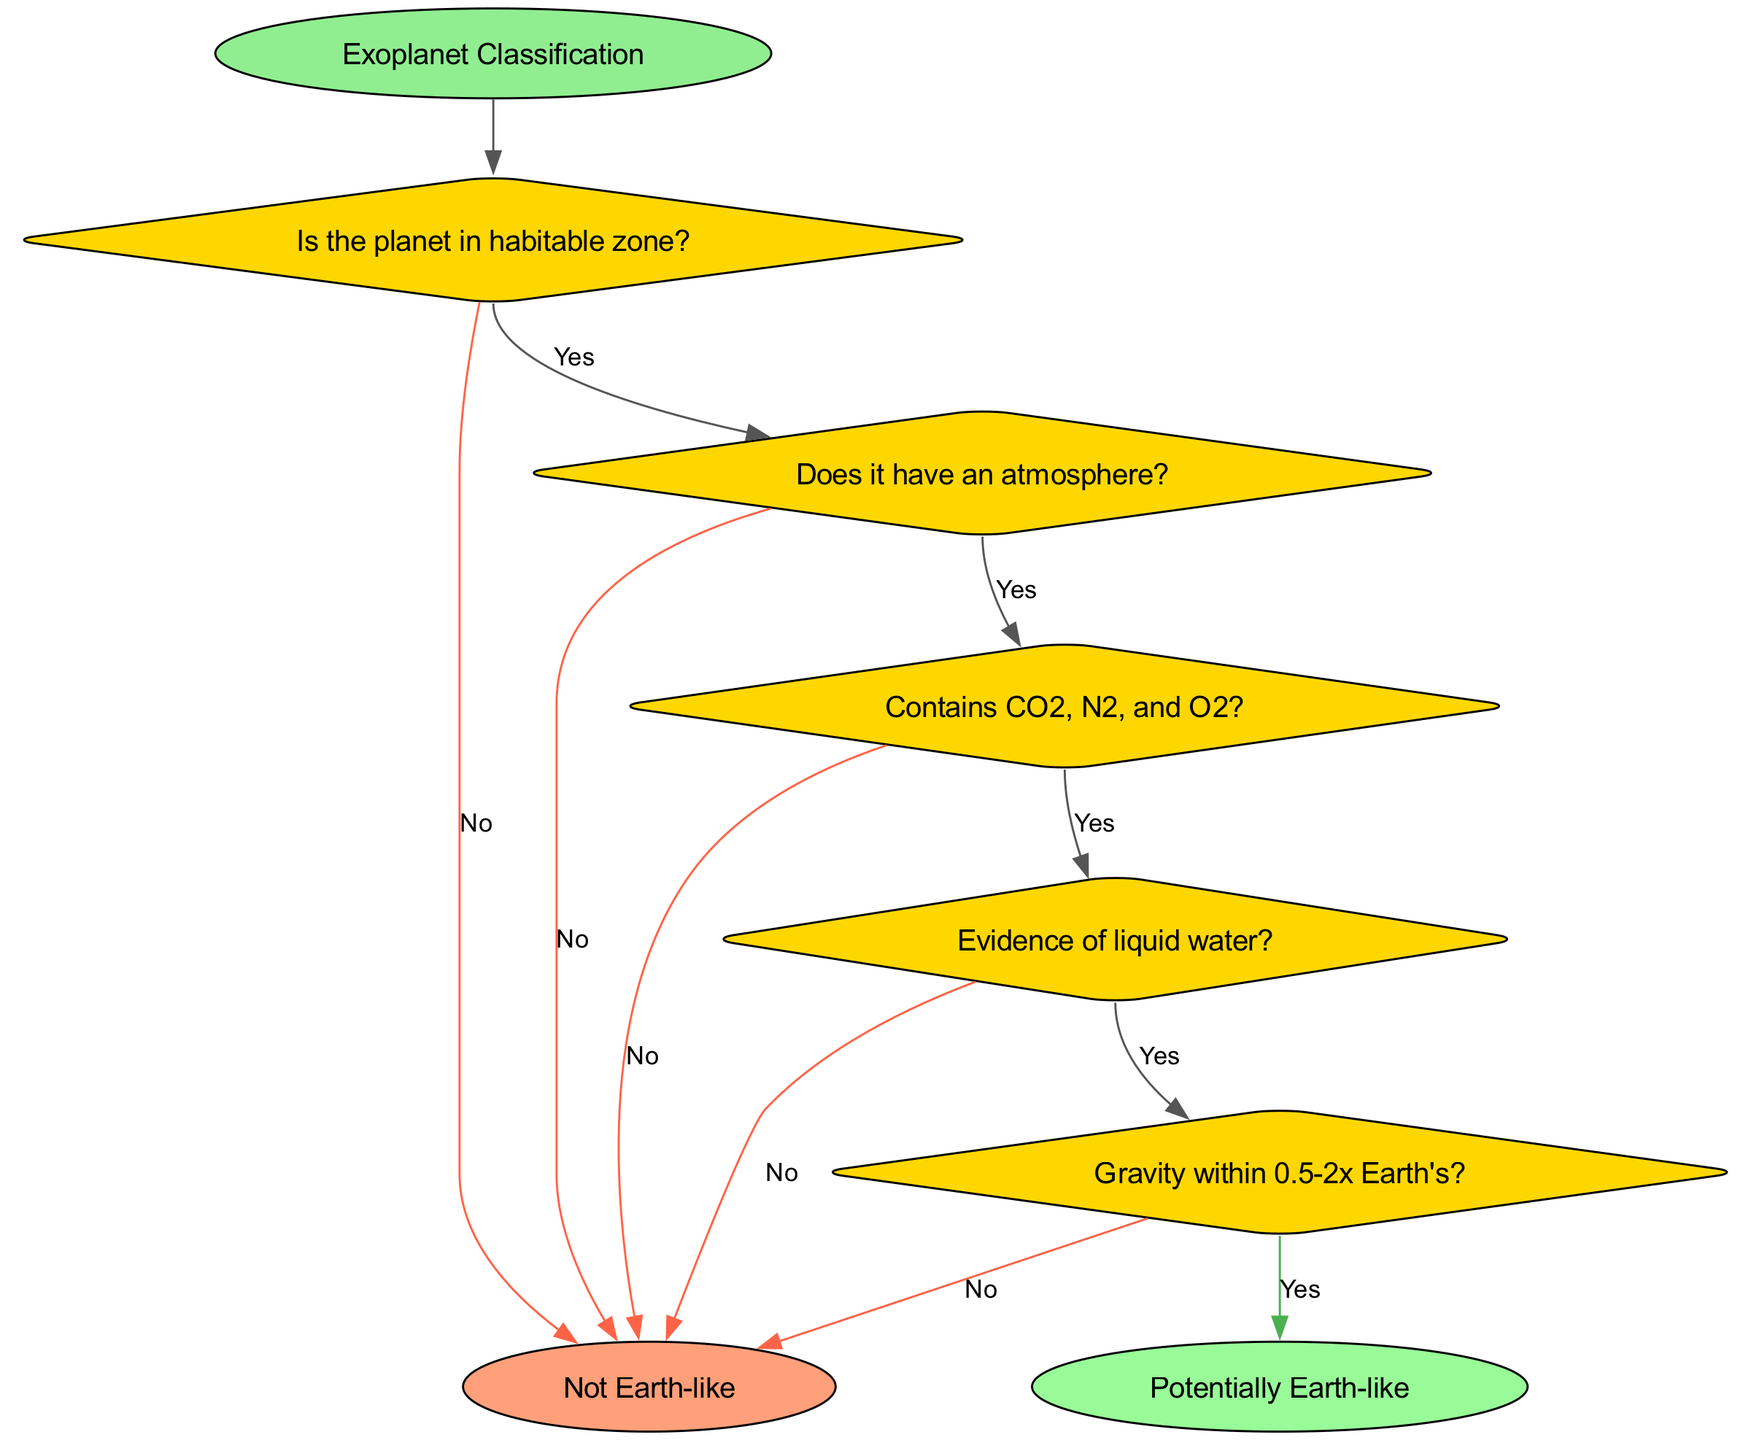Is the starting point labeled? The starting point of the diagram is labeled as "Exoplanet Classification," which indicates the beginning of this flowchart.
Answer: Exoplanet Classification How many decisions are made in the flowchart? There are five decision nodes in the flowchart, each representing a question to classify exoplanets.
Answer: 5 What is the outcome if the planet is not in the habitable zone? If the answer to the question "Is the planet in habitable zone?" is 'No,' it leads directly to the endpoint labeled "Not Earth-like."
Answer: Not Earth-like What is checked after confirming the planet has an atmosphere? After confirming that the planet has an atmosphere, the next question is "Contains CO2, N2, and O2?" which assesses the composition of the atmosphere.
Answer: Analyze composition What is the final assessment if gravity is within 0.5-2x Earth's? If the gravity falls within the range of 0.5-2x Earth's, the outcome is classified as "Potentially Earth-like." This indicates a positive assessment after going through all preceding questions.
Answer: Potentially Earth-like What happens if there is no evidence of liquid water? If the question "Evidence of liquid water?" is answered with 'No', the flowchart directs to the endpoint "Not Earth-like," thereby concluding the classification process without further assessment.
Answer: Not Earth-like What is the relationship between the atmosphere and the composition check? The atmosphere check is directly followed by an analysis of the composition. If the planet has an atmosphere, it necessitates checking for CO2, N2, and O2. This shows a dependency in the steps taken for classification.
Answer: Analyze composition 